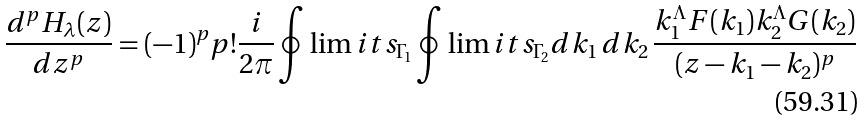Convert formula to latex. <formula><loc_0><loc_0><loc_500><loc_500>\frac { d ^ { p } H _ { \lambda } ( z ) } { d z ^ { p } } = ( - 1 ) ^ { p } p ! \frac { i } { 2 \pi } \oint \lim i t s _ { { \Gamma } _ { 1 } } \oint \lim i t s _ { { \Gamma } _ { 2 } } d k _ { 1 } \, d k _ { 2 } \, \frac { k _ { 1 } ^ { \Lambda } F ( k _ { 1 } ) k _ { 2 } ^ { \Lambda } G ( k _ { 2 } ) } { ( z - k _ { 1 } - k _ { 2 } ) ^ { p } }</formula> 